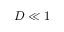Convert formula to latex. <formula><loc_0><loc_0><loc_500><loc_500>D \ll 1</formula> 